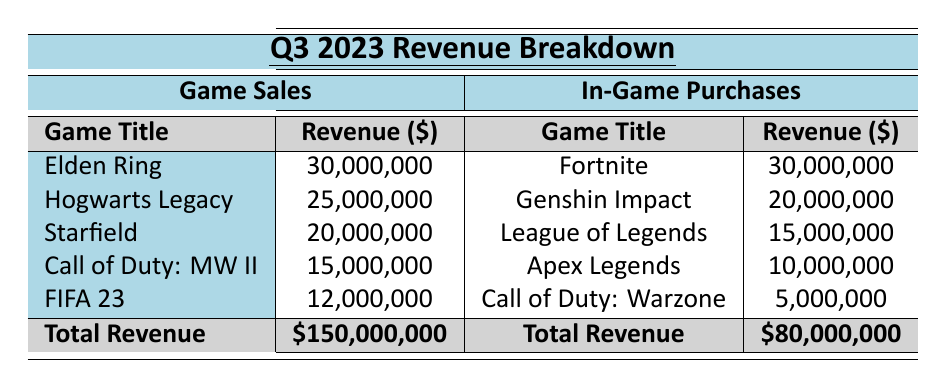What is the total revenue from game sales in Q3 2023? The total revenue from game sales is explicitly stated in the table as $150,000,000.
Answer: $150,000,000 What is the total revenue from in-game purchases in Q3 2023? The total revenue from in-game purchases is clearly listed in the table as $80,000,000.
Answer: $80,000,000 Which game had the highest revenue from in-game purchases? The highest revenue from in-game purchases is for Fortnite, with $30,000,000 as listed in the table.
Answer: Fortnite What is the revenue from the game "Starfield"? The revenue from "Starfield" is specified in the table as $20,000,000.
Answer: $20,000,000 How much more did game sales bring in compared to in-game purchases? The total revenue from game sales is $150,000,000 and from in-game purchases is $80,000,000. The difference is $150,000,000 - $80,000,000 = $70,000,000.
Answer: $70,000,000 What percentage of total game sales revenue does "Elden Ring" represent? The revenue for "Elden Ring" is $30,000,000 out of the total game sales of $150,000,000. To find the percentage, (30,000,000 / 150,000,000) * 100 = 20%.
Answer: 20% What are the total active users for the top two games in terms of in-game purchases? The top two games are "Fortnite" with 8,000,000 active users and "Genshin Impact" with 6,000,000 active users. Adding those gives 8,000,000 + 6,000,000 = 14,000,000 active users in total.
Answer: 14,000,000 Which game from the "Game Sales" category sold more than $15,000,000? The games that sold more than $15,000,000 are "Elden Ring," "Hogwarts Legacy," "Starfield," and "Call of Duty: Modern Warfare II."
Answer: Elden Ring, Hogwarts Legacy, Starfield, Call of Duty: Modern Warfare II Is it true that "Call of Duty: Warzone" had a higher revenue than "Apex Legends"? "Call of Duty: Warzone" generated $5,000,000 while "Apex Legends" generated $10,000,000, so it is false that Warzone had a higher revenue.
Answer: No Calculate the average revenue from the top five games in the "Game Sales" category. The total revenue from the top five games is $30,000,000 + $25,000,000 + $20,000,000 + $15,000,000 + $12,000,000 = $112,000,000. Dividing by 5 gives $112,000,000 / 5 = $22,400,000.
Answer: $22,400,000 